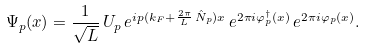<formula> <loc_0><loc_0><loc_500><loc_500>\Psi _ { p } ( x ) = \frac { 1 } { \sqrt { L } } \, U _ { p } \, e ^ { i p ( k _ { F } + \frac { 2 \pi } { L } \, \hat { N } _ { p } ) x } \, e ^ { 2 \pi i \varphi ^ { \dagger } _ { p } ( x ) } \, e ^ { 2 \pi i \varphi _ { p } ( x ) } .</formula> 